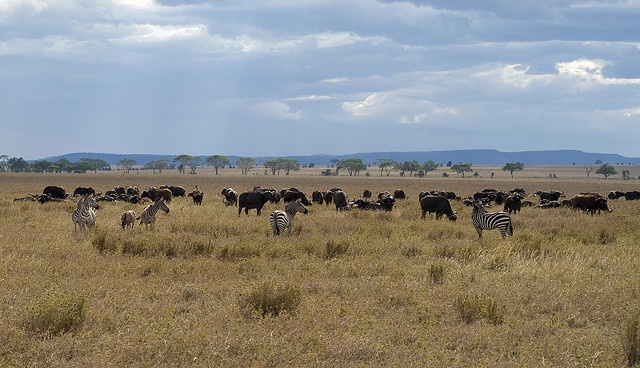Describe the objects in this image and their specific colors. I can see cow in white, black, and gray tones, zebra in white, black, gray, and darkgray tones, zebra in white, black, and gray tones, zebra in white, gray, and black tones, and cow in white, black, and gray tones in this image. 